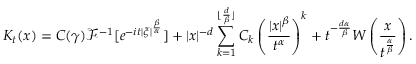Convert formula to latex. <formula><loc_0><loc_0><loc_500><loc_500>K _ { t } ( x ) = C ( \gamma ) \mathcal { F } ^ { - 1 } [ e ^ { - i t | \xi | ^ { \frac { \beta } { \alpha } } } ] + | x | ^ { - d } \sum _ { k = 1 } ^ { \lfloor \frac { d } { \beta } \rfloor } C _ { k } \left ( \frac { | x | ^ { \beta } } { t ^ { \alpha } } \right ) ^ { k } + t ^ { - \frac { d \alpha } { \beta } } W \left ( \frac { x } { t ^ { \frac { \alpha } { \beta } } } \right ) .</formula> 